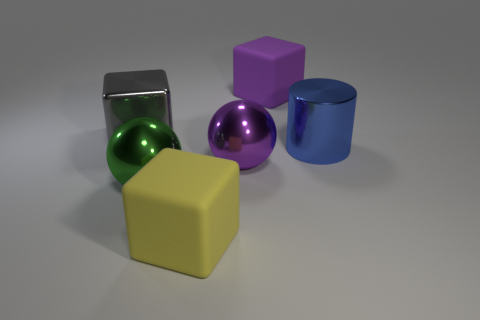Subtract all purple cubes. How many cubes are left? 2 Subtract all purple cubes. How many cubes are left? 2 Add 2 tiny green matte blocks. How many objects exist? 8 Subtract all balls. How many objects are left? 4 Subtract all purple cubes. How many green balls are left? 1 Subtract all yellow cubes. Subtract all small yellow rubber cubes. How many objects are left? 5 Add 2 big green metallic things. How many big green metallic things are left? 3 Add 6 blue shiny objects. How many blue shiny objects exist? 7 Subtract 0 brown cubes. How many objects are left? 6 Subtract 1 balls. How many balls are left? 1 